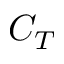Convert formula to latex. <formula><loc_0><loc_0><loc_500><loc_500>C _ { T }</formula> 